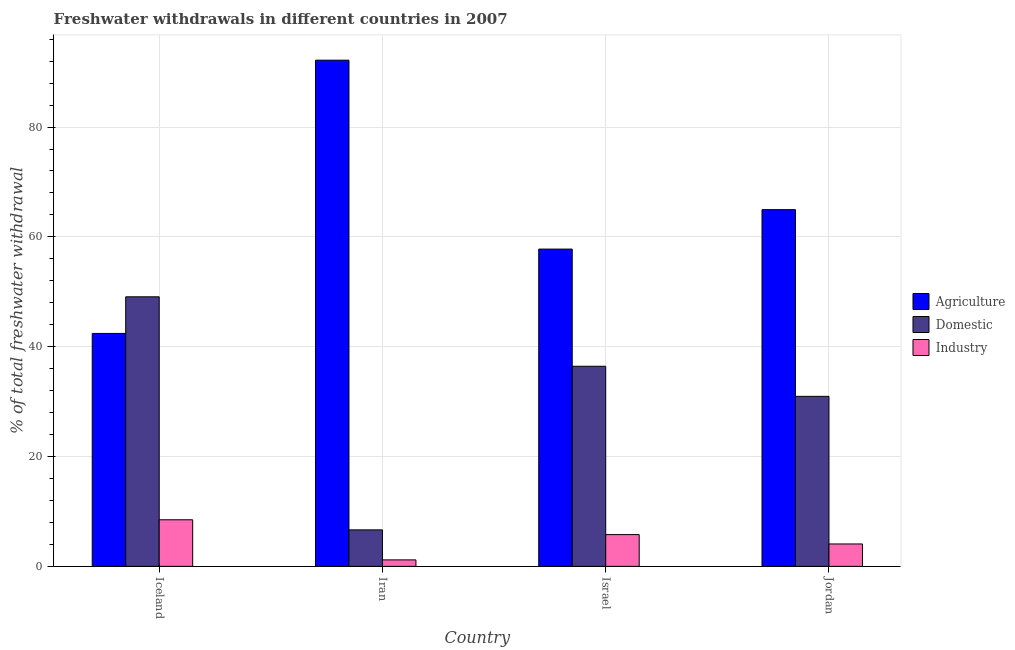How many groups of bars are there?
Provide a succinct answer. 4. Are the number of bars per tick equal to the number of legend labels?
Keep it short and to the point. Yes. Are the number of bars on each tick of the X-axis equal?
Provide a short and direct response. Yes. How many bars are there on the 1st tick from the right?
Provide a succinct answer. 3. What is the label of the 2nd group of bars from the left?
Make the answer very short. Iran. In how many cases, is the number of bars for a given country not equal to the number of legend labels?
Ensure brevity in your answer.  0. What is the percentage of freshwater withdrawal for industry in Jordan?
Your answer should be compact. 4.08. Across all countries, what is the maximum percentage of freshwater withdrawal for agriculture?
Provide a succinct answer. 92.18. Across all countries, what is the minimum percentage of freshwater withdrawal for industry?
Offer a very short reply. 1.18. In which country was the percentage of freshwater withdrawal for agriculture maximum?
Make the answer very short. Iran. In which country was the percentage of freshwater withdrawal for industry minimum?
Your response must be concise. Iran. What is the total percentage of freshwater withdrawal for domestic purposes in the graph?
Offer a terse response. 123.13. What is the difference between the percentage of freshwater withdrawal for agriculture in Iceland and that in Israel?
Offer a very short reply. -15.36. What is the difference between the percentage of freshwater withdrawal for agriculture in Israel and the percentage of freshwater withdrawal for industry in Iceland?
Provide a short and direct response. 49.3. What is the average percentage of freshwater withdrawal for domestic purposes per country?
Your answer should be very brief. 30.78. What is the difference between the percentage of freshwater withdrawal for domestic purposes and percentage of freshwater withdrawal for agriculture in Israel?
Offer a very short reply. -21.34. What is the ratio of the percentage of freshwater withdrawal for domestic purposes in Iceland to that in Iran?
Offer a terse response. 7.39. Is the percentage of freshwater withdrawal for industry in Iran less than that in Jordan?
Provide a short and direct response. Yes. What is the difference between the highest and the second highest percentage of freshwater withdrawal for domestic purposes?
Give a very brief answer. 12.65. What is the difference between the highest and the lowest percentage of freshwater withdrawal for agriculture?
Your response must be concise. 49.76. In how many countries, is the percentage of freshwater withdrawal for agriculture greater than the average percentage of freshwater withdrawal for agriculture taken over all countries?
Keep it short and to the point. 2. Is the sum of the percentage of freshwater withdrawal for industry in Iceland and Jordan greater than the maximum percentage of freshwater withdrawal for agriculture across all countries?
Keep it short and to the point. No. What does the 1st bar from the left in Jordan represents?
Provide a short and direct response. Agriculture. What does the 3rd bar from the right in Jordan represents?
Ensure brevity in your answer.  Agriculture. Is it the case that in every country, the sum of the percentage of freshwater withdrawal for agriculture and percentage of freshwater withdrawal for domestic purposes is greater than the percentage of freshwater withdrawal for industry?
Your answer should be compact. Yes. How many bars are there?
Ensure brevity in your answer.  12. Are all the bars in the graph horizontal?
Make the answer very short. No. What is the difference between two consecutive major ticks on the Y-axis?
Keep it short and to the point. 20. Does the graph contain any zero values?
Provide a succinct answer. No. How are the legend labels stacked?
Offer a terse response. Vertical. What is the title of the graph?
Your answer should be very brief. Freshwater withdrawals in different countries in 2007. Does "Slovak Republic" appear as one of the legend labels in the graph?
Your answer should be very brief. No. What is the label or title of the X-axis?
Your response must be concise. Country. What is the label or title of the Y-axis?
Ensure brevity in your answer.  % of total freshwater withdrawal. What is the % of total freshwater withdrawal of Agriculture in Iceland?
Offer a very short reply. 42.42. What is the % of total freshwater withdrawal of Domestic in Iceland?
Ensure brevity in your answer.  49.09. What is the % of total freshwater withdrawal in Industry in Iceland?
Keep it short and to the point. 8.48. What is the % of total freshwater withdrawal of Agriculture in Iran?
Keep it short and to the point. 92.18. What is the % of total freshwater withdrawal of Domestic in Iran?
Ensure brevity in your answer.  6.64. What is the % of total freshwater withdrawal in Industry in Iran?
Your response must be concise. 1.18. What is the % of total freshwater withdrawal of Agriculture in Israel?
Provide a short and direct response. 57.78. What is the % of total freshwater withdrawal in Domestic in Israel?
Your answer should be very brief. 36.44. What is the % of total freshwater withdrawal in Industry in Israel?
Offer a very short reply. 5.78. What is the % of total freshwater withdrawal in Agriculture in Jordan?
Your answer should be compact. 64.96. What is the % of total freshwater withdrawal in Domestic in Jordan?
Your answer should be very brief. 30.96. What is the % of total freshwater withdrawal in Industry in Jordan?
Offer a very short reply. 4.08. Across all countries, what is the maximum % of total freshwater withdrawal in Agriculture?
Offer a very short reply. 92.18. Across all countries, what is the maximum % of total freshwater withdrawal in Domestic?
Offer a very short reply. 49.09. Across all countries, what is the maximum % of total freshwater withdrawal of Industry?
Your answer should be very brief. 8.48. Across all countries, what is the minimum % of total freshwater withdrawal in Agriculture?
Provide a succinct answer. 42.42. Across all countries, what is the minimum % of total freshwater withdrawal of Domestic?
Offer a terse response. 6.64. Across all countries, what is the minimum % of total freshwater withdrawal of Industry?
Ensure brevity in your answer.  1.18. What is the total % of total freshwater withdrawal in Agriculture in the graph?
Give a very brief answer. 257.34. What is the total % of total freshwater withdrawal in Domestic in the graph?
Give a very brief answer. 123.14. What is the total % of total freshwater withdrawal of Industry in the graph?
Make the answer very short. 19.53. What is the difference between the % of total freshwater withdrawal of Agriculture in Iceland and that in Iran?
Your answer should be compact. -49.76. What is the difference between the % of total freshwater withdrawal of Domestic in Iceland and that in Iran?
Keep it short and to the point. 42.45. What is the difference between the % of total freshwater withdrawal of Industry in Iceland and that in Iran?
Provide a succinct answer. 7.31. What is the difference between the % of total freshwater withdrawal of Agriculture in Iceland and that in Israel?
Make the answer very short. -15.36. What is the difference between the % of total freshwater withdrawal in Domestic in Iceland and that in Israel?
Your answer should be very brief. 12.65. What is the difference between the % of total freshwater withdrawal in Industry in Iceland and that in Israel?
Provide a succinct answer. 2.7. What is the difference between the % of total freshwater withdrawal of Agriculture in Iceland and that in Jordan?
Ensure brevity in your answer.  -22.54. What is the difference between the % of total freshwater withdrawal in Domestic in Iceland and that in Jordan?
Your answer should be very brief. 18.13. What is the difference between the % of total freshwater withdrawal of Industry in Iceland and that in Jordan?
Keep it short and to the point. 4.4. What is the difference between the % of total freshwater withdrawal of Agriculture in Iran and that in Israel?
Offer a very short reply. 34.4. What is the difference between the % of total freshwater withdrawal in Domestic in Iran and that in Israel?
Your response must be concise. -29.8. What is the difference between the % of total freshwater withdrawal in Industry in Iran and that in Israel?
Your answer should be compact. -4.6. What is the difference between the % of total freshwater withdrawal of Agriculture in Iran and that in Jordan?
Your response must be concise. 27.22. What is the difference between the % of total freshwater withdrawal in Domestic in Iran and that in Jordan?
Your answer should be compact. -24.32. What is the difference between the % of total freshwater withdrawal of Industry in Iran and that in Jordan?
Keep it short and to the point. -2.9. What is the difference between the % of total freshwater withdrawal in Agriculture in Israel and that in Jordan?
Ensure brevity in your answer.  -7.18. What is the difference between the % of total freshwater withdrawal of Domestic in Israel and that in Jordan?
Offer a terse response. 5.48. What is the difference between the % of total freshwater withdrawal in Industry in Israel and that in Jordan?
Give a very brief answer. 1.7. What is the difference between the % of total freshwater withdrawal in Agriculture in Iceland and the % of total freshwater withdrawal in Domestic in Iran?
Keep it short and to the point. 35.77. What is the difference between the % of total freshwater withdrawal of Agriculture in Iceland and the % of total freshwater withdrawal of Industry in Iran?
Your answer should be very brief. 41.24. What is the difference between the % of total freshwater withdrawal of Domestic in Iceland and the % of total freshwater withdrawal of Industry in Iran?
Your answer should be compact. 47.91. What is the difference between the % of total freshwater withdrawal in Agriculture in Iceland and the % of total freshwater withdrawal in Domestic in Israel?
Offer a very short reply. 5.98. What is the difference between the % of total freshwater withdrawal of Agriculture in Iceland and the % of total freshwater withdrawal of Industry in Israel?
Your response must be concise. 36.64. What is the difference between the % of total freshwater withdrawal in Domestic in Iceland and the % of total freshwater withdrawal in Industry in Israel?
Offer a terse response. 43.31. What is the difference between the % of total freshwater withdrawal of Agriculture in Iceland and the % of total freshwater withdrawal of Domestic in Jordan?
Give a very brief answer. 11.46. What is the difference between the % of total freshwater withdrawal in Agriculture in Iceland and the % of total freshwater withdrawal in Industry in Jordan?
Make the answer very short. 38.34. What is the difference between the % of total freshwater withdrawal in Domestic in Iceland and the % of total freshwater withdrawal in Industry in Jordan?
Your answer should be very brief. 45.01. What is the difference between the % of total freshwater withdrawal of Agriculture in Iran and the % of total freshwater withdrawal of Domestic in Israel?
Make the answer very short. 55.74. What is the difference between the % of total freshwater withdrawal of Agriculture in Iran and the % of total freshwater withdrawal of Industry in Israel?
Your answer should be very brief. 86.4. What is the difference between the % of total freshwater withdrawal of Domestic in Iran and the % of total freshwater withdrawal of Industry in Israel?
Provide a succinct answer. 0.86. What is the difference between the % of total freshwater withdrawal of Agriculture in Iran and the % of total freshwater withdrawal of Domestic in Jordan?
Ensure brevity in your answer.  61.22. What is the difference between the % of total freshwater withdrawal of Agriculture in Iran and the % of total freshwater withdrawal of Industry in Jordan?
Keep it short and to the point. 88.1. What is the difference between the % of total freshwater withdrawal of Domestic in Iran and the % of total freshwater withdrawal of Industry in Jordan?
Give a very brief answer. 2.56. What is the difference between the % of total freshwater withdrawal of Agriculture in Israel and the % of total freshwater withdrawal of Domestic in Jordan?
Provide a short and direct response. 26.82. What is the difference between the % of total freshwater withdrawal in Agriculture in Israel and the % of total freshwater withdrawal in Industry in Jordan?
Offer a very short reply. 53.7. What is the difference between the % of total freshwater withdrawal of Domestic in Israel and the % of total freshwater withdrawal of Industry in Jordan?
Give a very brief answer. 32.36. What is the average % of total freshwater withdrawal in Agriculture per country?
Offer a terse response. 64.33. What is the average % of total freshwater withdrawal of Domestic per country?
Offer a terse response. 30.78. What is the average % of total freshwater withdrawal in Industry per country?
Your answer should be compact. 4.88. What is the difference between the % of total freshwater withdrawal in Agriculture and % of total freshwater withdrawal in Domestic in Iceland?
Ensure brevity in your answer.  -6.67. What is the difference between the % of total freshwater withdrawal in Agriculture and % of total freshwater withdrawal in Industry in Iceland?
Make the answer very short. 33.94. What is the difference between the % of total freshwater withdrawal in Domestic and % of total freshwater withdrawal in Industry in Iceland?
Make the answer very short. 40.6. What is the difference between the % of total freshwater withdrawal of Agriculture and % of total freshwater withdrawal of Domestic in Iran?
Your response must be concise. 85.53. What is the difference between the % of total freshwater withdrawal of Agriculture and % of total freshwater withdrawal of Industry in Iran?
Your answer should be very brief. 91. What is the difference between the % of total freshwater withdrawal in Domestic and % of total freshwater withdrawal in Industry in Iran?
Provide a succinct answer. 5.47. What is the difference between the % of total freshwater withdrawal in Agriculture and % of total freshwater withdrawal in Domestic in Israel?
Keep it short and to the point. 21.34. What is the difference between the % of total freshwater withdrawal in Agriculture and % of total freshwater withdrawal in Industry in Israel?
Provide a succinct answer. 52. What is the difference between the % of total freshwater withdrawal of Domestic and % of total freshwater withdrawal of Industry in Israel?
Make the answer very short. 30.66. What is the difference between the % of total freshwater withdrawal in Agriculture and % of total freshwater withdrawal in Industry in Jordan?
Keep it short and to the point. 60.88. What is the difference between the % of total freshwater withdrawal of Domestic and % of total freshwater withdrawal of Industry in Jordan?
Keep it short and to the point. 26.88. What is the ratio of the % of total freshwater withdrawal in Agriculture in Iceland to that in Iran?
Offer a very short reply. 0.46. What is the ratio of the % of total freshwater withdrawal in Domestic in Iceland to that in Iran?
Give a very brief answer. 7.39. What is the ratio of the % of total freshwater withdrawal in Industry in Iceland to that in Iran?
Your response must be concise. 7.2. What is the ratio of the % of total freshwater withdrawal of Agriculture in Iceland to that in Israel?
Give a very brief answer. 0.73. What is the ratio of the % of total freshwater withdrawal of Domestic in Iceland to that in Israel?
Your answer should be compact. 1.35. What is the ratio of the % of total freshwater withdrawal of Industry in Iceland to that in Israel?
Your response must be concise. 1.47. What is the ratio of the % of total freshwater withdrawal in Agriculture in Iceland to that in Jordan?
Make the answer very short. 0.65. What is the ratio of the % of total freshwater withdrawal of Domestic in Iceland to that in Jordan?
Ensure brevity in your answer.  1.59. What is the ratio of the % of total freshwater withdrawal in Industry in Iceland to that in Jordan?
Offer a very short reply. 2.08. What is the ratio of the % of total freshwater withdrawal in Agriculture in Iran to that in Israel?
Your answer should be compact. 1.6. What is the ratio of the % of total freshwater withdrawal in Domestic in Iran to that in Israel?
Keep it short and to the point. 0.18. What is the ratio of the % of total freshwater withdrawal in Industry in Iran to that in Israel?
Offer a very short reply. 0.2. What is the ratio of the % of total freshwater withdrawal of Agriculture in Iran to that in Jordan?
Your answer should be compact. 1.42. What is the ratio of the % of total freshwater withdrawal of Domestic in Iran to that in Jordan?
Your answer should be compact. 0.21. What is the ratio of the % of total freshwater withdrawal of Industry in Iran to that in Jordan?
Offer a very short reply. 0.29. What is the ratio of the % of total freshwater withdrawal of Agriculture in Israel to that in Jordan?
Ensure brevity in your answer.  0.89. What is the ratio of the % of total freshwater withdrawal of Domestic in Israel to that in Jordan?
Offer a very short reply. 1.18. What is the ratio of the % of total freshwater withdrawal of Industry in Israel to that in Jordan?
Provide a short and direct response. 1.42. What is the difference between the highest and the second highest % of total freshwater withdrawal in Agriculture?
Make the answer very short. 27.22. What is the difference between the highest and the second highest % of total freshwater withdrawal in Domestic?
Make the answer very short. 12.65. What is the difference between the highest and the second highest % of total freshwater withdrawal of Industry?
Your response must be concise. 2.7. What is the difference between the highest and the lowest % of total freshwater withdrawal in Agriculture?
Provide a succinct answer. 49.76. What is the difference between the highest and the lowest % of total freshwater withdrawal in Domestic?
Provide a short and direct response. 42.45. What is the difference between the highest and the lowest % of total freshwater withdrawal in Industry?
Ensure brevity in your answer.  7.31. 